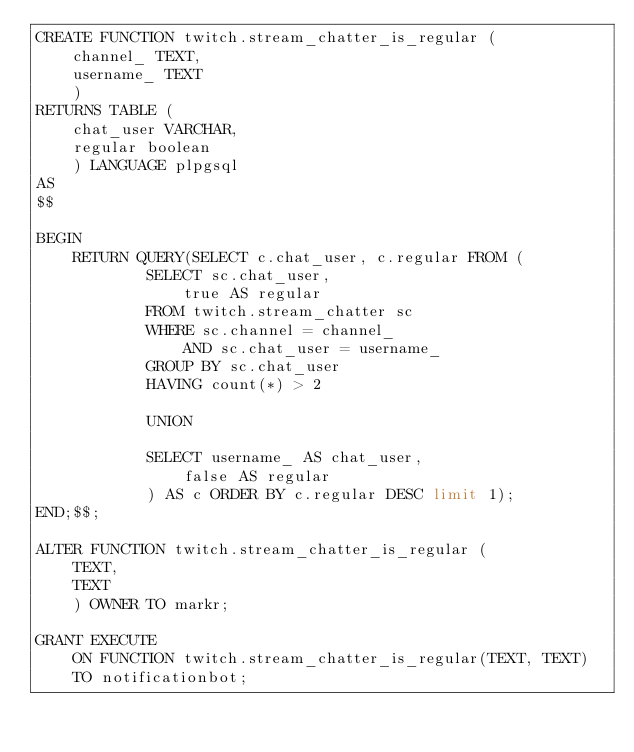Convert code to text. <code><loc_0><loc_0><loc_500><loc_500><_SQL_>CREATE FUNCTION twitch.stream_chatter_is_regular (
    channel_ TEXT,
    username_ TEXT
    )
RETURNS TABLE (
    chat_user VARCHAR,
    regular boolean
    ) LANGUAGE plpgsql
AS
$$

BEGIN
    RETURN QUERY(SELECT c.chat_user, c.regular FROM (
            SELECT sc.chat_user,
                true AS regular
            FROM twitch.stream_chatter sc
            WHERE sc.channel = channel_
                AND sc.chat_user = username_
            GROUP BY sc.chat_user
            HAVING count(*) > 2
            
            UNION
            
            SELECT username_ AS chat_user,
                false AS regular
            ) AS c ORDER BY c.regular DESC limit 1);
END;$$;

ALTER FUNCTION twitch.stream_chatter_is_regular (
    TEXT,
    TEXT
    ) OWNER TO markr;

GRANT EXECUTE
    ON FUNCTION twitch.stream_chatter_is_regular(TEXT, TEXT)
    TO notificationbot;
</code> 